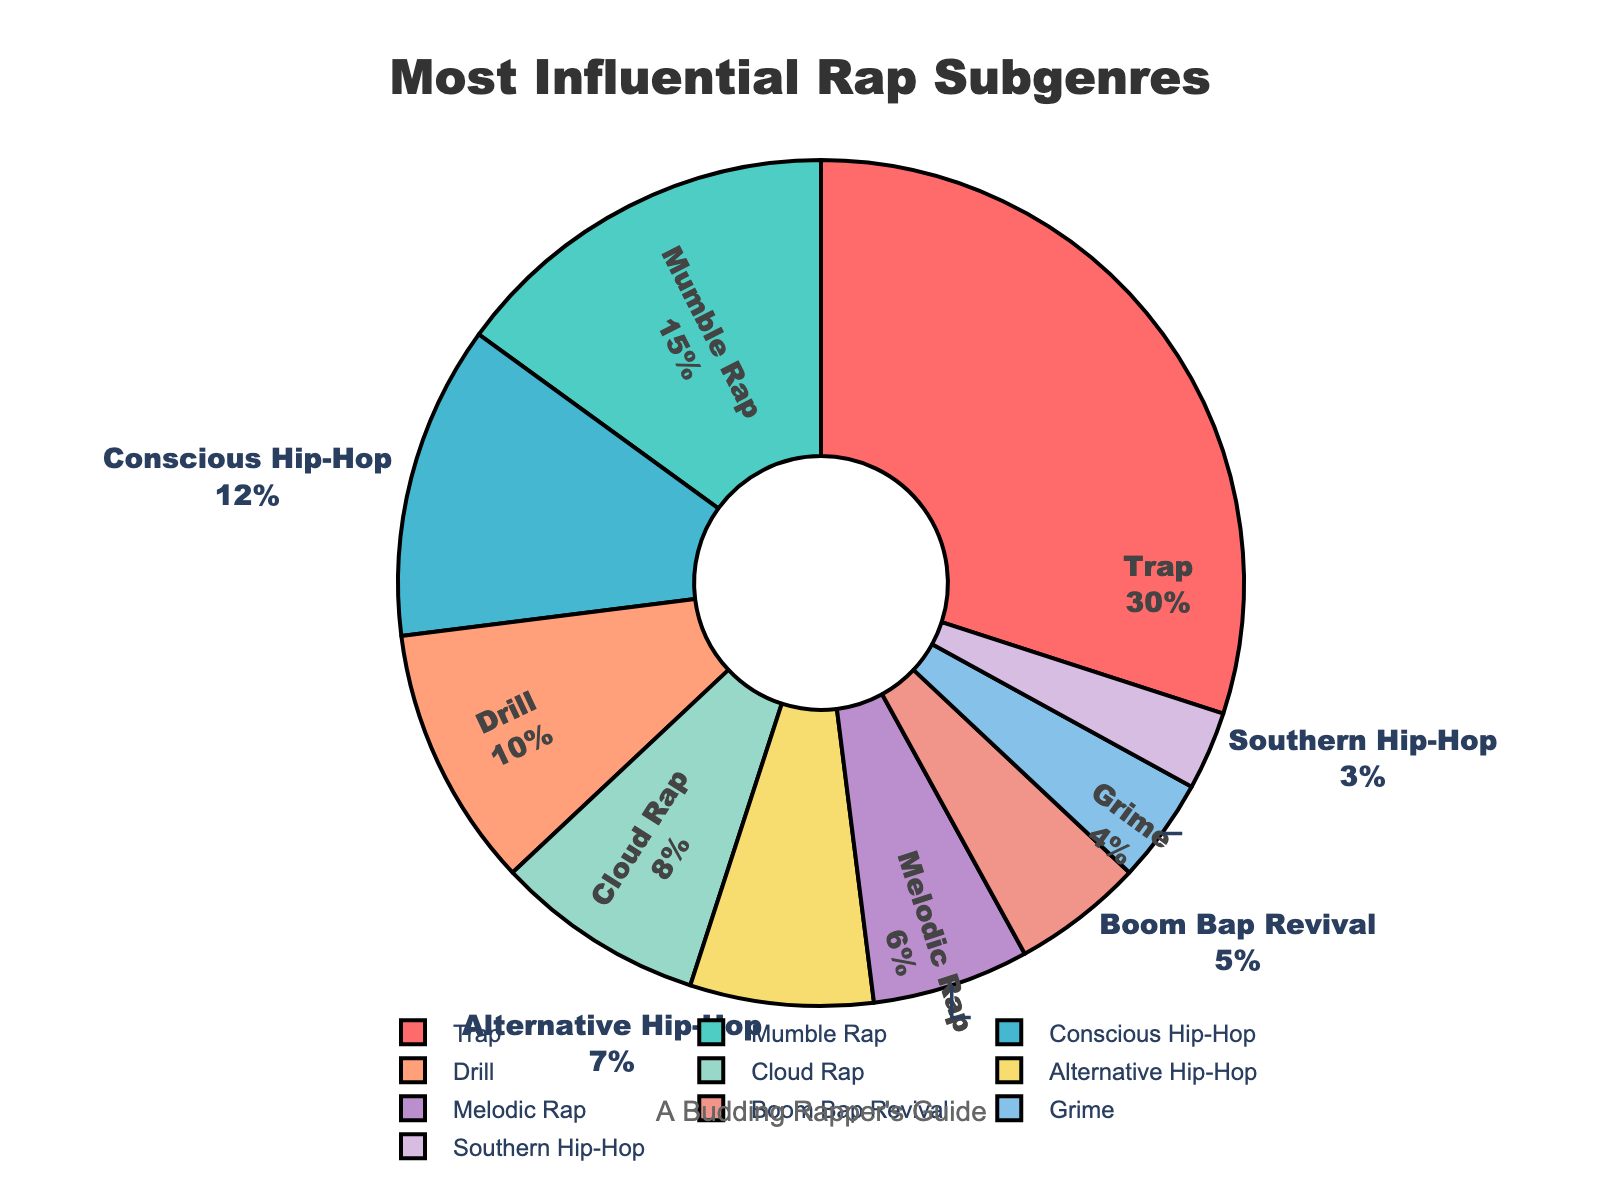What is the most influential rap subgenre? The most influential rap subgenre can be identified by looking at the slice with the largest percentage. The largest slice represents 30% and is labeled as Trap.
Answer: Trap Which subgenre has a higher percentage, Drill or Melodic Rap? To find which subgenre has a higher percentage, compare the Drill slice (10%) directly with the Melodic Rap slice (6%). Drill has a higher percentage.
Answer: Drill What is the combined percentage of Conscious Hip-Hop and Alternative Hip-Hop? Add the percentages of Conscious Hip-Hop (12%) and Alternative Hip-Hop (7%) together. The combined percentage is 12% + 7% = 19%.
Answer: 19% Which subgenre occupies the smallest slice and what is its percentage? To find the smallest slice, look for the subgenre with the least percentage value. Southern Hip-Hop has the smallest slice with 3%.
Answer: Southern Hip-Hop, 3% How much more influential is Trap compared to Boom Bap Revival? Subtract the percentage of Boom Bap Revival (5%) from the percentage of Trap (30%). 30% - 5% = 25%.
Answer: 25% What three subgenres occupy the second, third, and fourth largest slices? Identify the subgenres with the second, third, and fourth highest percentages. Mumble Rap (15%) is second, Conscious Hip-Hop (12%) is third, and Drill (10%) is fourth.
Answer: Mumble Rap, Conscious Hip-Hop, Drill Which slice is colored in light green? Look at the color scheme to identify which slice corresponds to light green. The light green slice is labeled with "Cloud Rap," and its percentage is 8%.
Answer: Cloud Rap If you combine the percentages of all subgenres except for the three most influential ones, what percentage do you get? Subtract the combined percentage of the three most influential subgenres (Trap 30%, Mumble Rap 15%, Conscious Hip-Hop 12%) from 100%. 30% + 15% + 12% = 57%, then 100% - 57% = 43%.
Answer: 43% What is the average percentage of the subgenres with less than 10% influence? Identify subgenres with less than 10%: Drill (10%), Cloud Rap (8%), Alternative Hip-Hop (7%), Melodic Rap (6%), Boom Bap Revival (5%), Grime (4%), Southern Hip-Hop (3%). Then, sum their percentages and divide by the number of these subgenres: (10 + 8 + 7 + 6 + 5 + 4 + 3) / 7 ≈ 6.14%.
Answer: ~6.14% What is one reason why a subgenre might have a smaller slice on the pie chart? A subgenre might have a smaller slice on the pie chart because it has a lower percentage of influence compared to other subgenres.
Answer: Lower influence percentage 